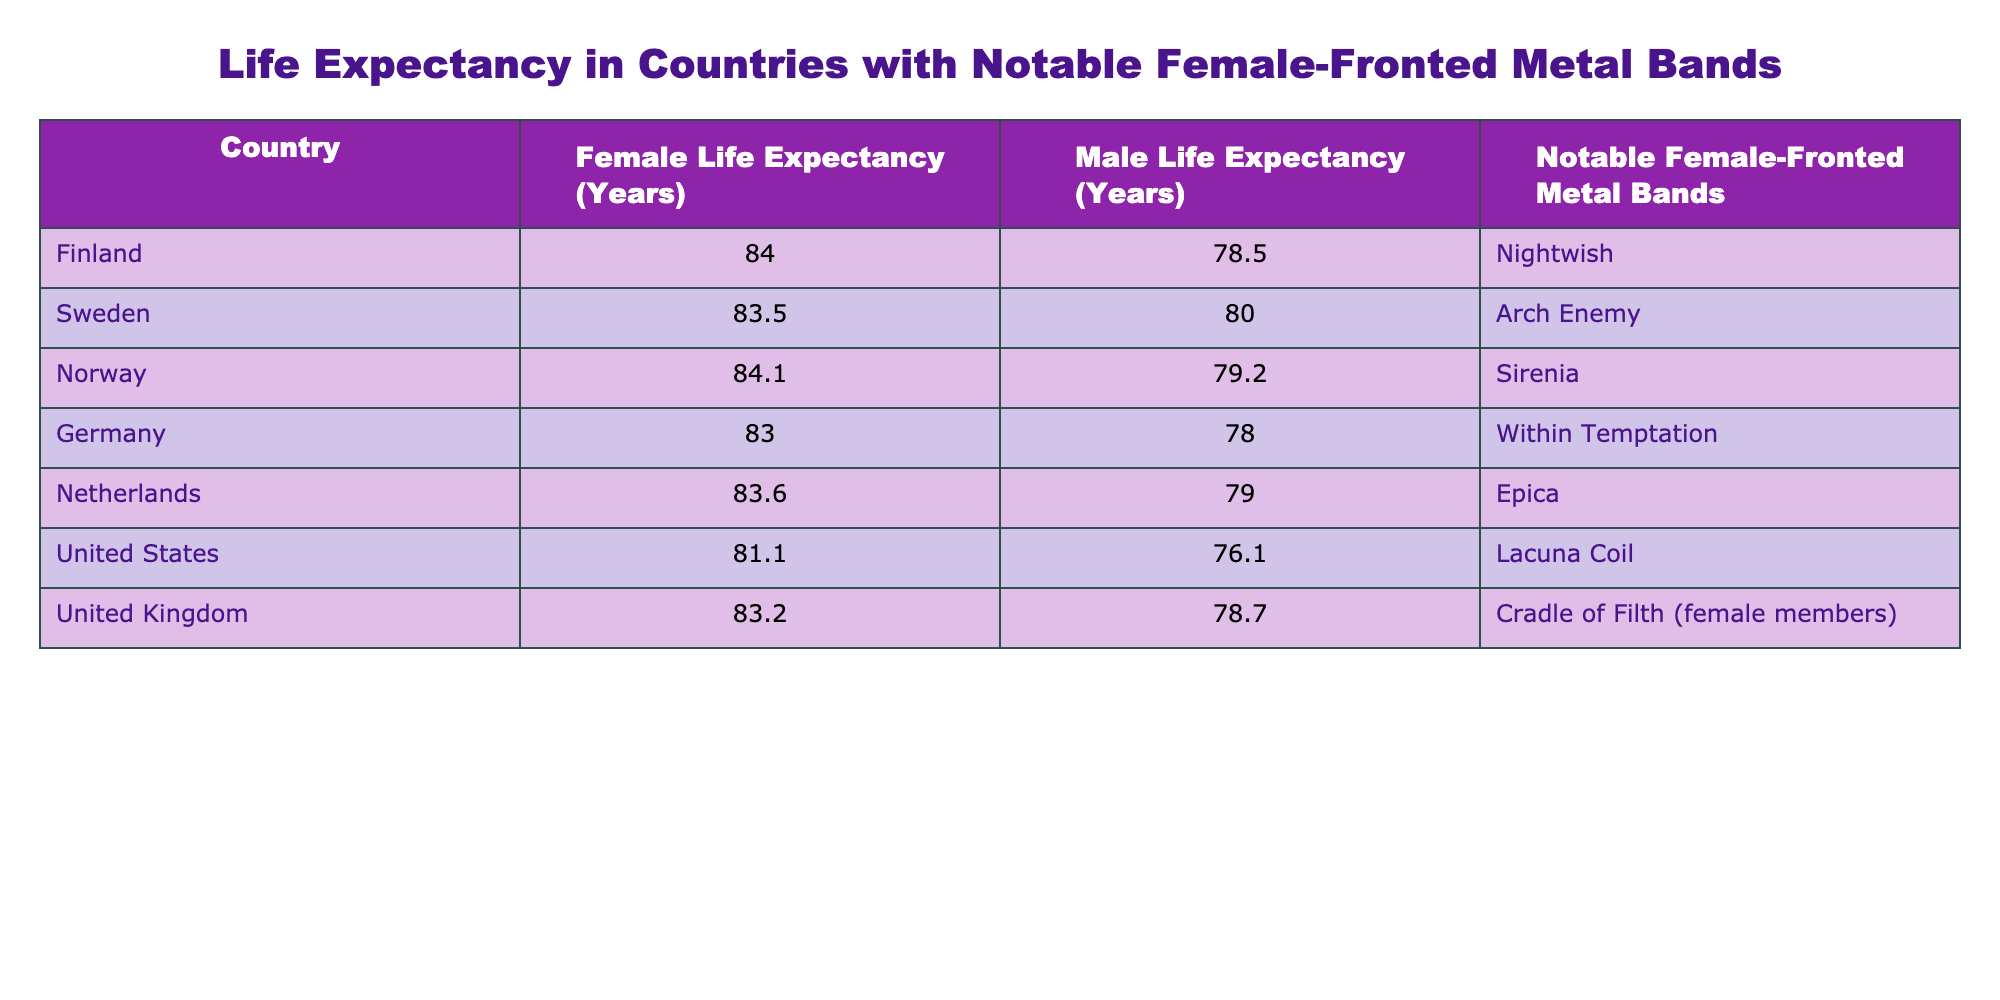What is the female life expectancy in Finland? From the table, the female life expectancy in Finland is listed directly under that column. It states 84.0 years as the value for Finland
Answer: 84.0 years Which country has the highest male life expectancy? To find this, we compare the values in the "Male Life Expectancy" column. Norway has the highest male life expectancy, which is 79.2 years
Answer: 79.2 years What is the difference in life expectancy between females and males in the United States? The female life expectancy in the United States is 81.1 years, and the male life expectancy is 76.1 years. The difference is calculated as 81.1 - 76.1 = 5.0 years
Answer: 5.0 years Is Sweden known for a notable female-fronted metal band? The table shows "Arch Enemy" listed under Sweden. This confirms that Sweden is known for a notable female-fronted metal band
Answer: Yes What is the average female life expectancy of the countries listed in the table? To calculate the average, sum the female life expectancy values: 84.0 + 83.5 + 84.1 + 83.0 + 83.6 + 81.1 + 83.2 =  502.5. There are 7 data points, so the average is 502.5 / 7 ≈ 71.79 years
Answer: 71.79 years Which country has the lowest female life expectancy among those listed? By examining the female life expectancy values, the United States has the lowest value at 81.1 years when compared to others
Answer: 81.1 years Which country has a female life expectancy greater than 83 years but less than 84 years? Looking through the table, Sweden (83.5 years) and Germany (83.0 years) meet the condition of being greater than 83 years and less than 84 years
Answer: Sweden and Germany Is there a country in the table with a male life expectancy below 77 years? Reviewing the "Male Life Expectancy" column, the United States with 76.1 years has a male life expectancy below 77 years
Answer: Yes What is the combined life expectancy of females from Germany and Norway? The female life expectancy in Germany is 83.0 years and in Norway it is 84.1 years. Combining these yields a total of 83.0 + 84.1 = 167.1 years
Answer: 167.1 years 